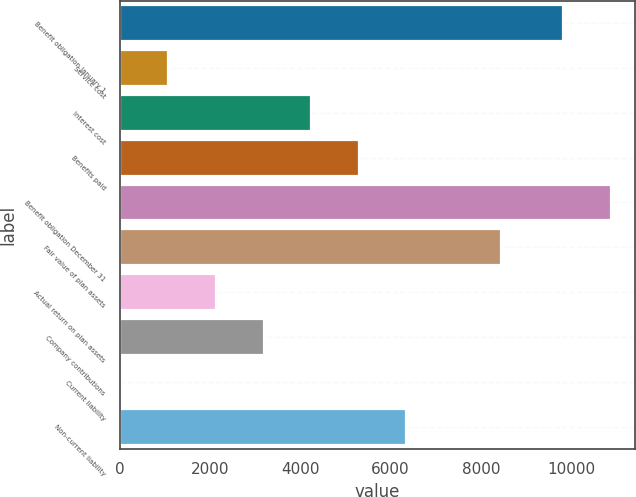Convert chart to OTSL. <chart><loc_0><loc_0><loc_500><loc_500><bar_chart><fcel>Benefit obligation January 1<fcel>Service cost<fcel>Interest cost<fcel>Benefits paid<fcel>Benefit obligation December 31<fcel>Fair value of plan assets<fcel>Actual return on plan assets<fcel>Company contributions<fcel>Current liability<fcel>Non-current liability<nl><fcel>9824<fcel>1084.3<fcel>4241.2<fcel>5293.5<fcel>10876.3<fcel>8450.4<fcel>2136.6<fcel>3188.9<fcel>32<fcel>6345.8<nl></chart> 